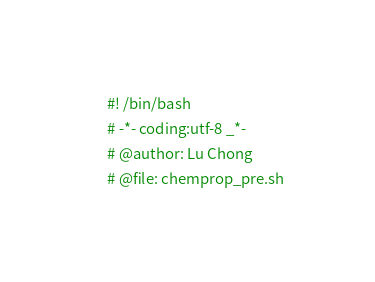Convert code to text. <code><loc_0><loc_0><loc_500><loc_500><_Bash_>#! /bin/bash
# -*- coding:utf-8 _*-
# @author: Lu Chong
# @file: chemprop_pre.sh</code> 